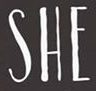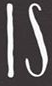Identify the words shown in these images in order, separated by a semicolon. SHE; IS 